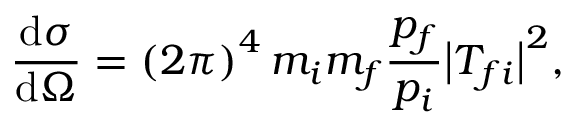<formula> <loc_0><loc_0><loc_500><loc_500>{ \frac { d \sigma } { d \Omega } } = \left ( 2 \pi \right ) ^ { 4 } m _ { i } m _ { f } { \frac { p _ { f } } { p _ { i } } } { \left | } T _ { f i } { \right | } ^ { 2 } ,</formula> 